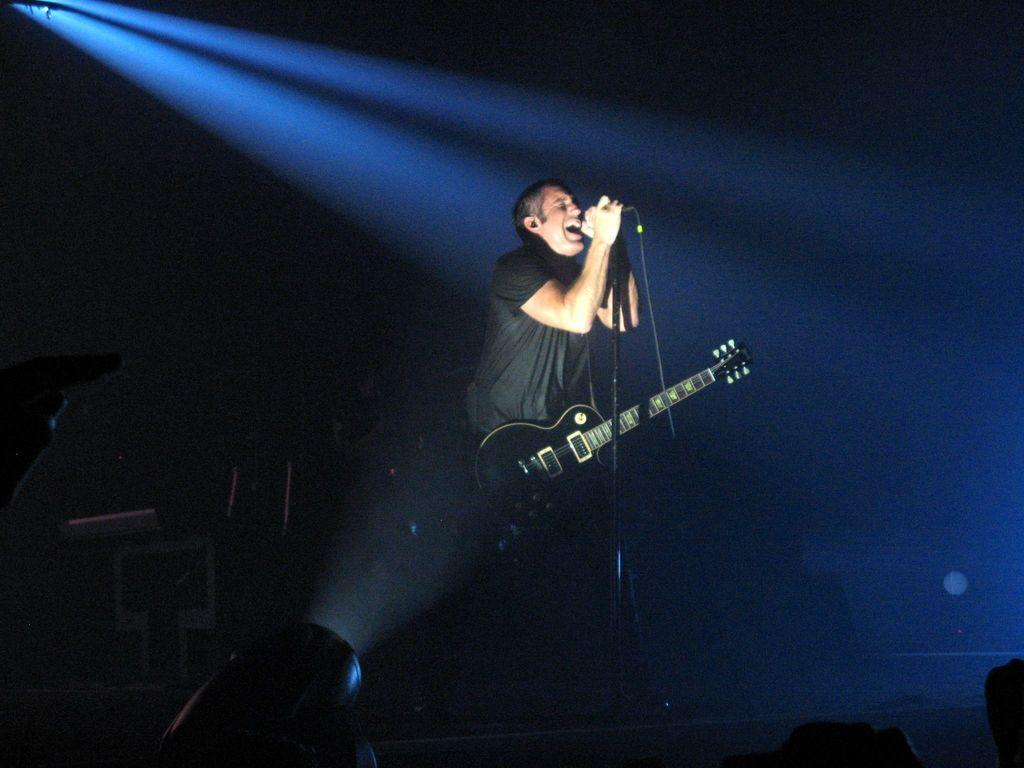What is the main subject of the image? There is a person in the image. What is the person doing in the image? The person is standing and holding a guitar and a microphone. What can be seen in the background of the image? The background of the image is dark. What additional feature is present in the image? There is a focus light in the image. How old is the person's grandfather in the image? There is no mention of a grandfather or any family members in the image, so we cannot determine the age of the person's grandfather. Is the person in the image a boy or a girl? The image does not provide any information about the person's gender, so we cannot determine if they are a boy or a girl. 